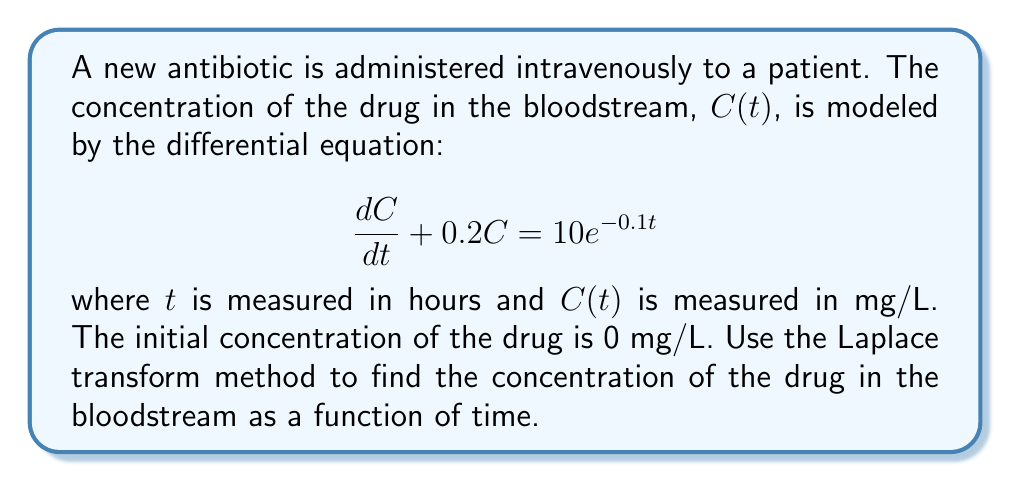Teach me how to tackle this problem. Let's solve this step-by-step using the Laplace transform method:

1) First, we take the Laplace transform of both sides of the equation. Let $\mathcal{L}\{C(t)\} = Y(s)$.

   $$\mathcal{L}\{\frac{dC}{dt} + 0.2C\} = \mathcal{L}\{10e^{-0.1t}\}$$

2) Using Laplace transform properties:

   $$sY(s) - C(0) + 0.2Y(s) = \frac{10}{s+0.1}$$

3) We know that $C(0) = 0$, so:

   $$(s + 0.2)Y(s) = \frac{10}{s+0.1}$$

4) Solve for $Y(s)$:

   $$Y(s) = \frac{10}{(s+0.2)(s+0.1)}$$

5) To find the inverse Laplace transform, we need to use partial fraction decomposition:

   $$Y(s) = \frac{A}{s+0.2} + \frac{B}{s+0.1}$$

   where $A$ and $B$ are constants we need to determine.

6) Finding $A$ and $B$:

   $$10 = A(s+0.1) + B(s+0.2)$$
   
   When $s = -0.2$: $10 = A(-0.1) - B(0)$, so $A = -100$
   When $s = -0.1$: $10 = A(0) + B(0.1)$, so $B = 100$

7) Therefore:

   $$Y(s) = \frac{-100}{s+0.2} + \frac{100}{s+0.1}$$

8) Taking the inverse Laplace transform:

   $$C(t) = -100e^{-0.2t} + 100e^{-0.1t}$$

This is the concentration of the drug in the bloodstream as a function of time.
Answer: $C(t) = 100(e^{-0.1t} - e^{-0.2t})$ mg/L 